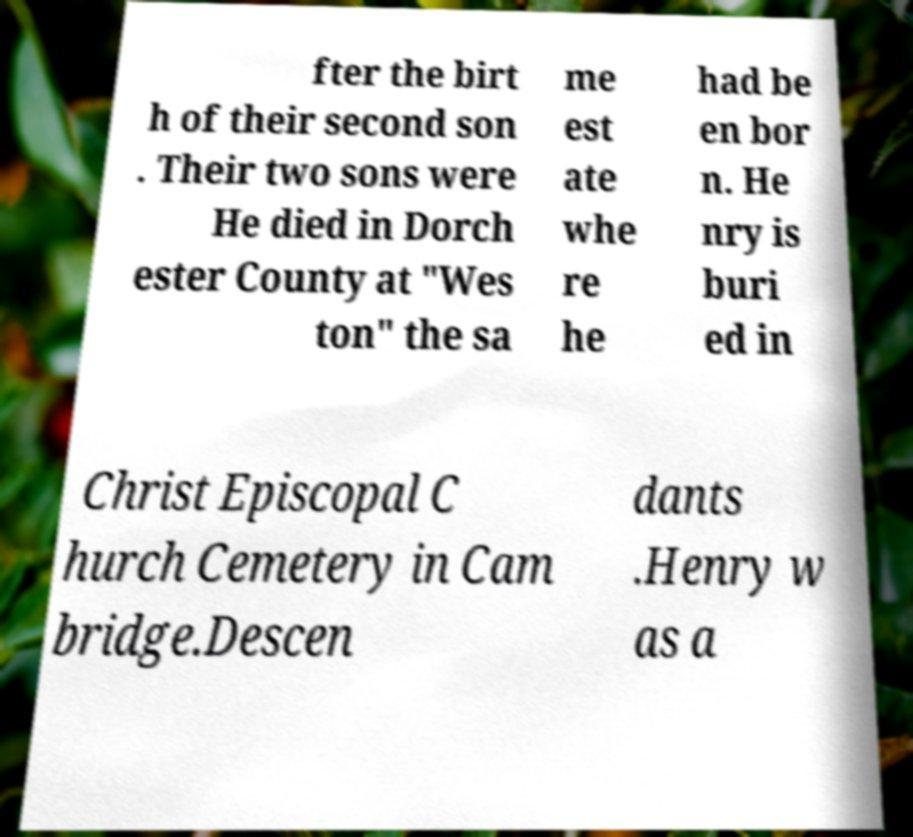Can you read and provide the text displayed in the image?This photo seems to have some interesting text. Can you extract and type it out for me? fter the birt h of their second son . Their two sons were He died in Dorch ester County at "Wes ton" the sa me est ate whe re he had be en bor n. He nry is buri ed in Christ Episcopal C hurch Cemetery in Cam bridge.Descen dants .Henry w as a 